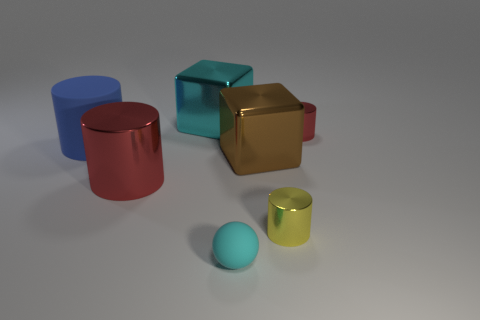How many objects are either small metal objects right of the cyan cube or small rubber spheres?
Make the answer very short. 3. What shape is the large metal thing that is the same color as the ball?
Your answer should be very brief. Cube. The cyan object in front of the red metal cylinder in front of the blue rubber cylinder is made of what material?
Ensure brevity in your answer.  Rubber. Is there a tiny cylinder that has the same material as the blue object?
Your answer should be compact. No. Is there a brown cube that is on the right side of the shiny cylinder behind the blue cylinder?
Ensure brevity in your answer.  No. What is the cyan object that is on the left side of the small cyan object made of?
Make the answer very short. Metal. Is the shape of the tiny cyan matte thing the same as the big brown shiny thing?
Your answer should be compact. No. There is a big cube that is to the right of the cyan thing behind the red metal thing that is behind the big metallic cylinder; what is its color?
Your answer should be very brief. Brown. What number of other objects are the same shape as the blue rubber object?
Your answer should be compact. 3. There is a red object to the left of the red metal object to the right of the rubber ball; what is its size?
Your response must be concise. Large. 